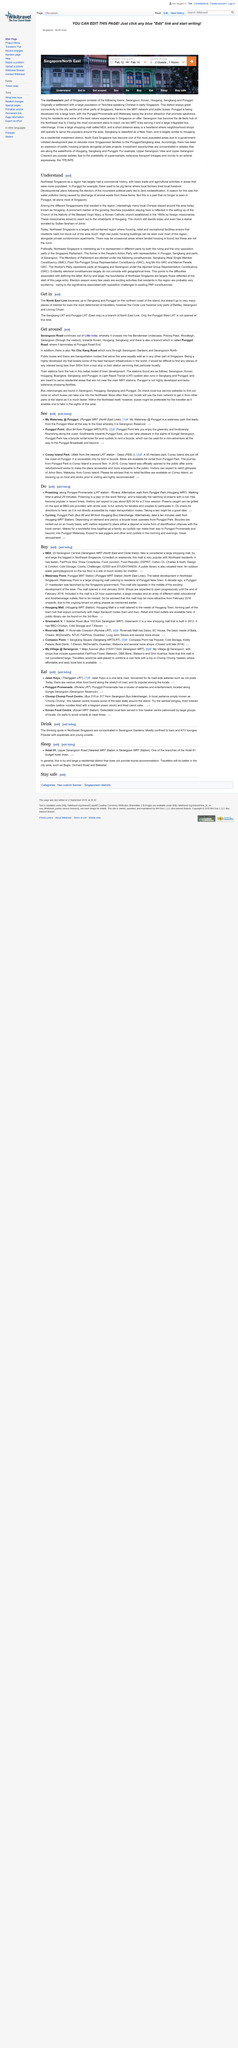List a handful of essential elements in this visual. The public library in Hougang Mall is located on the third floor. In Singapore, there are public libraries located in several shopping malls, including NEX and Hougang Mall. In Singapore, both train stations and bus interchanges are located in four cities, namely Serangoon, Hougang, Sengkang, and Punggol. These cities provide convenient transportation options for the residents and visitors to explore the different areas of the city. In the past, Punggol farms breed pigs as their main livestock. Four towns in Northeast Singapore are Punggol, Hougang, Serangoon, and Sengkang. 